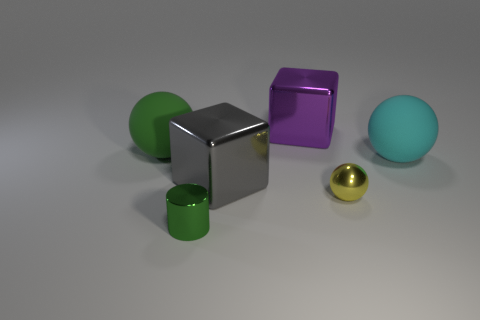Add 3 tiny yellow balls. How many objects exist? 9 Subtract all cubes. How many objects are left? 4 Add 4 gray shiny cylinders. How many gray shiny cylinders exist? 4 Subtract 0 red cylinders. How many objects are left? 6 Subtract all metal things. Subtract all cyan things. How many objects are left? 1 Add 2 purple cubes. How many purple cubes are left? 3 